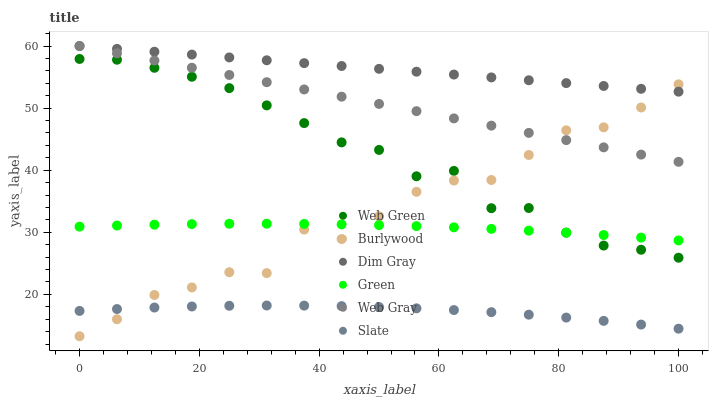Does Slate have the minimum area under the curve?
Answer yes or no. Yes. Does Dim Gray have the maximum area under the curve?
Answer yes or no. Yes. Does Burlywood have the minimum area under the curve?
Answer yes or no. No. Does Burlywood have the maximum area under the curve?
Answer yes or no. No. Is Web Gray the smoothest?
Answer yes or no. Yes. Is Burlywood the roughest?
Answer yes or no. Yes. Is Slate the smoothest?
Answer yes or no. No. Is Slate the roughest?
Answer yes or no. No. Does Burlywood have the lowest value?
Answer yes or no. Yes. Does Slate have the lowest value?
Answer yes or no. No. Does Web Gray have the highest value?
Answer yes or no. Yes. Does Burlywood have the highest value?
Answer yes or no. No. Is Web Green less than Dim Gray?
Answer yes or no. Yes. Is Dim Gray greater than Slate?
Answer yes or no. Yes. Does Web Gray intersect Burlywood?
Answer yes or no. Yes. Is Web Gray less than Burlywood?
Answer yes or no. No. Is Web Gray greater than Burlywood?
Answer yes or no. No. Does Web Green intersect Dim Gray?
Answer yes or no. No. 